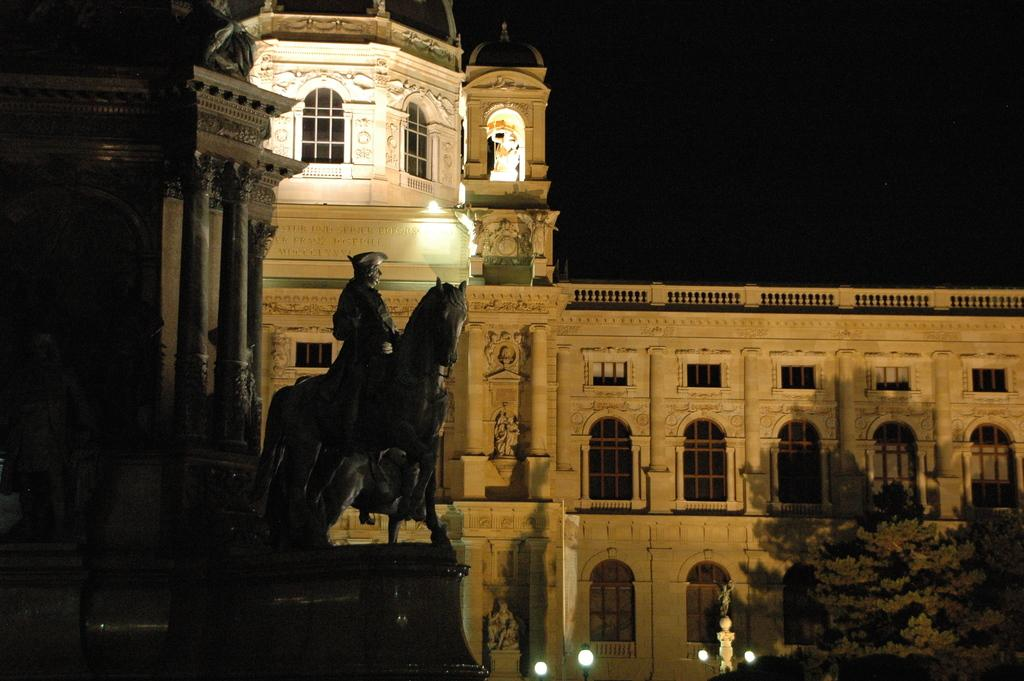What type of structure is in the image? There is a historical building in the image. What can be seen near the building? There is a sculpture of a man on a horse near the building. What lighting elements are present in the image? There are lamps visible in the image. What type of plant is in the image? There is a tree in the image. What flavor of cake is being served at the historical building in the image? There is no cake present in the image, so it is not possible to determine the flavor. 